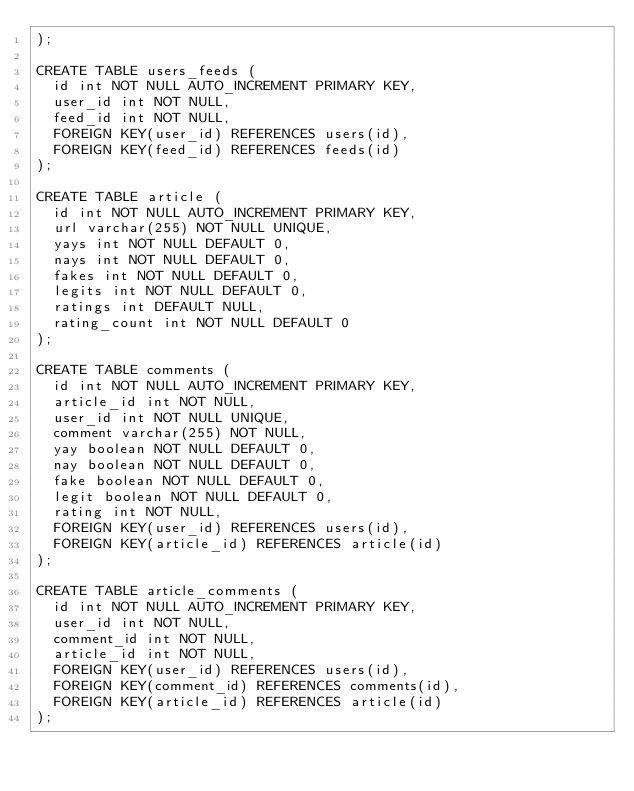Convert code to text. <code><loc_0><loc_0><loc_500><loc_500><_SQL_>);

CREATE TABLE users_feeds (
  id int NOT NULL AUTO_INCREMENT PRIMARY KEY,
  user_id int NOT NULL,
  feed_id int NOT NULL,
  FOREIGN KEY(user_id) REFERENCES users(id),
  FOREIGN KEY(feed_id) REFERENCES feeds(id)
);

CREATE TABLE article (
  id int NOT NULL AUTO_INCREMENT PRIMARY KEY,
  url varchar(255) NOT NULL UNIQUE,
  yays int NOT NULL DEFAULT 0,
  nays int NOT NULL DEFAULT 0,
  fakes int NOT NULL DEFAULT 0,
  legits int NOT NULL DEFAULT 0,
  ratings int DEFAULT NULL,
  rating_count int NOT NULL DEFAULT 0
);

CREATE TABLE comments (
  id int NOT NULL AUTO_INCREMENT PRIMARY KEY,
  article_id int NOT NULL,
  user_id int NOT NULL UNIQUE,
  comment varchar(255) NOT NULL,
  yay boolean NOT NULL DEFAULT 0,
  nay boolean NOT NULL DEFAULT 0,
  fake boolean NOT NULL DEFAULT 0,
  legit boolean NOT NULL DEFAULT 0,
  rating int NOT NULL,
  FOREIGN KEY(user_id) REFERENCES users(id),
  FOREIGN KEY(article_id) REFERENCES article(id)
);

CREATE TABLE article_comments (
  id int NOT NULL AUTO_INCREMENT PRIMARY KEY,
  user_id int NOT NULL,
  comment_id int NOT NULL,
  article_id int NOT NULL,
  FOREIGN KEY(user_id) REFERENCES users(id),
  FOREIGN KEY(comment_id) REFERENCES comments(id),
  FOREIGN KEY(article_id) REFERENCES article(id)
);
</code> 